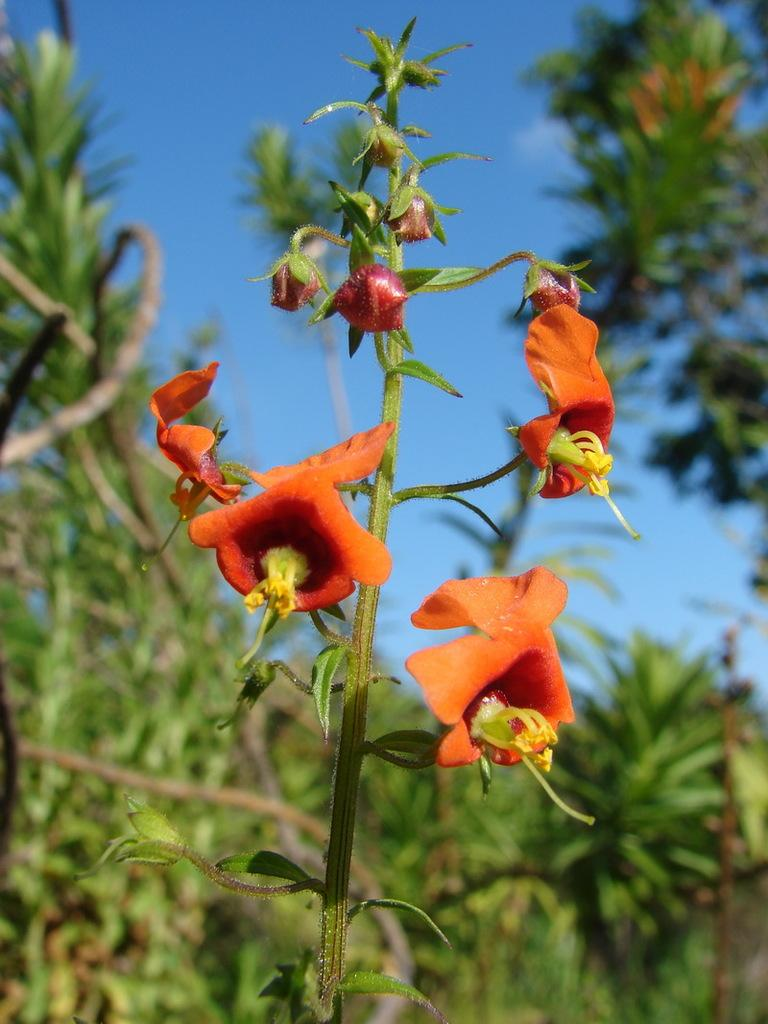What type of plant is in the image? There is a plant in the image, but the specific type cannot be determined from the facts provided. What can be seen on the plant in the image? There are flowers and buds visible on the plant in the image. What colors are present in the background of the image? The background of the image is blue and green. What part of the natural environment is visible in the image? The sky is visible in the background of the image. How many women are walking in the image? There are no women present in the image; it features a plant with flowers and buds against a blue and green background with the sky visible. 